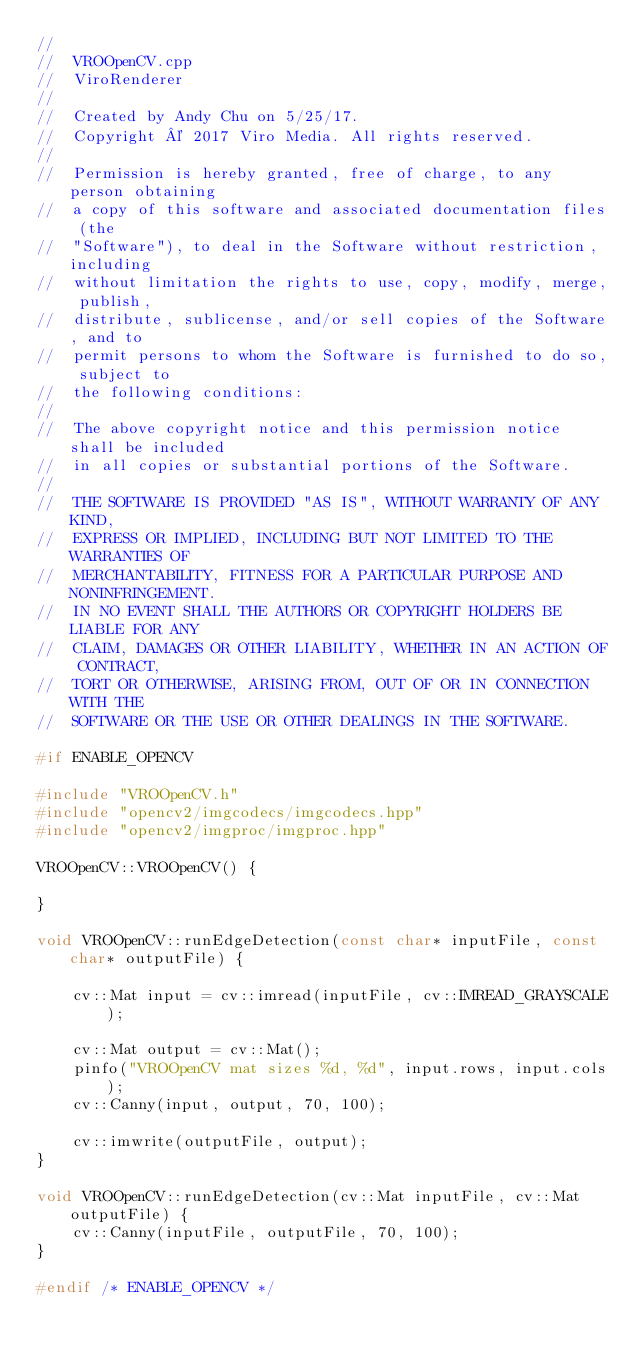<code> <loc_0><loc_0><loc_500><loc_500><_C++_>//
//  VROOpenCV.cpp
//  ViroRenderer
//
//  Created by Andy Chu on 5/25/17.
//  Copyright © 2017 Viro Media. All rights reserved.
//
//  Permission is hereby granted, free of charge, to any person obtaining
//  a copy of this software and associated documentation files (the
//  "Software"), to deal in the Software without restriction, including
//  without limitation the rights to use, copy, modify, merge, publish,
//  distribute, sublicense, and/or sell copies of the Software, and to
//  permit persons to whom the Software is furnished to do so, subject to
//  the following conditions:
//
//  The above copyright notice and this permission notice shall be included
//  in all copies or substantial portions of the Software.
//
//  THE SOFTWARE IS PROVIDED "AS IS", WITHOUT WARRANTY OF ANY KIND,
//  EXPRESS OR IMPLIED, INCLUDING BUT NOT LIMITED TO THE WARRANTIES OF
//  MERCHANTABILITY, FITNESS FOR A PARTICULAR PURPOSE AND NONINFRINGEMENT.
//  IN NO EVENT SHALL THE AUTHORS OR COPYRIGHT HOLDERS BE LIABLE FOR ANY
//  CLAIM, DAMAGES OR OTHER LIABILITY, WHETHER IN AN ACTION OF CONTRACT,
//  TORT OR OTHERWISE, ARISING FROM, OUT OF OR IN CONNECTION WITH THE
//  SOFTWARE OR THE USE OR OTHER DEALINGS IN THE SOFTWARE.

#if ENABLE_OPENCV

#include "VROOpenCV.h"
#include "opencv2/imgcodecs/imgcodecs.hpp"
#include "opencv2/imgproc/imgproc.hpp"

VROOpenCV::VROOpenCV() {
  
}

void VROOpenCV::runEdgeDetection(const char* inputFile, const char* outputFile) {
  
    cv::Mat input = cv::imread(inputFile, cv::IMREAD_GRAYSCALE);

    cv::Mat output = cv::Mat();
    pinfo("VROOpenCV mat sizes %d, %d", input.rows, input.cols);
    cv::Canny(input, output, 70, 100);
  
    cv::imwrite(outputFile, output);
}

void VROOpenCV::runEdgeDetection(cv::Mat inputFile, cv::Mat outputFile) {
    cv::Canny(inputFile, outputFile, 70, 100);
}

#endif /* ENABLE_OPENCV */
</code> 